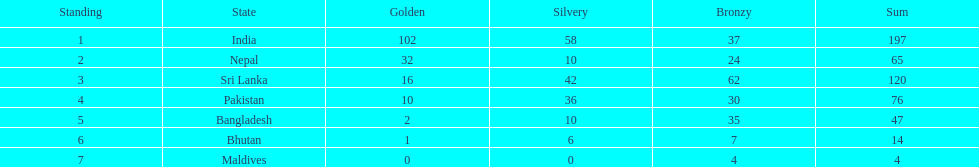What was the only nation to win less than 10 medals total? Maldives. 